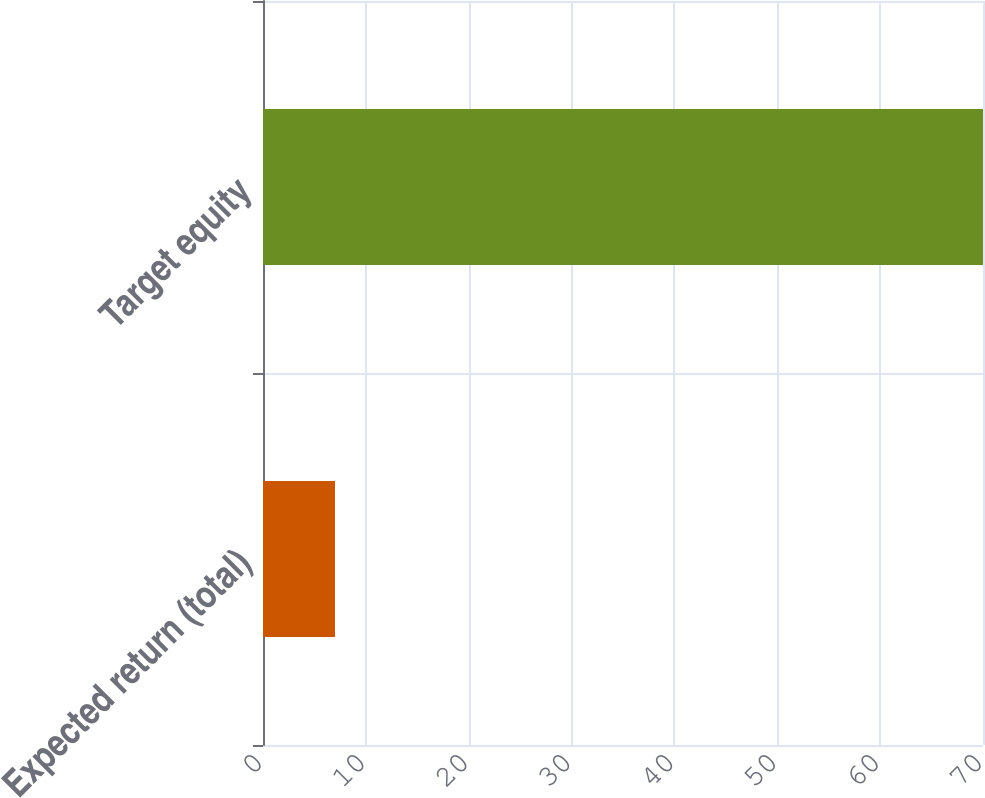Convert chart to OTSL. <chart><loc_0><loc_0><loc_500><loc_500><bar_chart><fcel>Expected return (total)<fcel>Target equity<nl><fcel>7<fcel>70<nl></chart> 